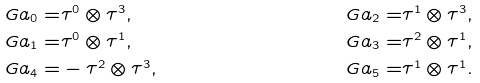Convert formula to latex. <formula><loc_0><loc_0><loc_500><loc_500>\ G a _ { 0 } = & \tau ^ { 0 } \otimes \tau ^ { 3 } , & \ G a _ { 2 } = & \tau ^ { 1 } \otimes \tau ^ { 3 } , \\ \ G a _ { 1 } = & \tau ^ { 0 } \otimes \tau ^ { 1 } , & \ G a _ { 3 } = & \tau ^ { 2 } \otimes \tau ^ { 1 } , \\ \ G a _ { 4 } = & - \tau ^ { 2 } \otimes \tau ^ { 3 } , & \ G a _ { 5 } = & \tau ^ { 1 } \otimes \tau ^ { 1 } .</formula> 